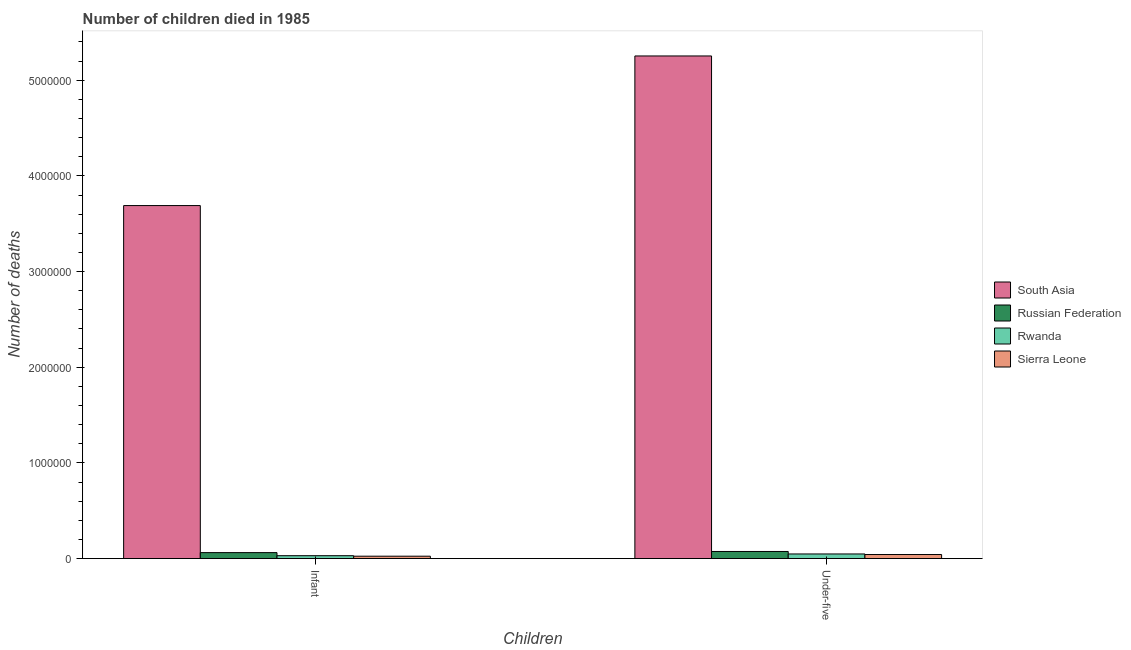How many bars are there on the 2nd tick from the left?
Your response must be concise. 4. What is the label of the 2nd group of bars from the left?
Offer a terse response. Under-five. What is the number of infant deaths in Russian Federation?
Offer a very short reply. 6.23e+04. Across all countries, what is the maximum number of under-five deaths?
Make the answer very short. 5.25e+06. Across all countries, what is the minimum number of under-five deaths?
Ensure brevity in your answer.  4.22e+04. In which country was the number of infant deaths maximum?
Ensure brevity in your answer.  South Asia. In which country was the number of infant deaths minimum?
Provide a succinct answer. Sierra Leone. What is the total number of under-five deaths in the graph?
Give a very brief answer. 5.42e+06. What is the difference between the number of infant deaths in South Asia and that in Russian Federation?
Ensure brevity in your answer.  3.63e+06. What is the difference between the number of infant deaths in Russian Federation and the number of under-five deaths in Sierra Leone?
Your answer should be very brief. 2.01e+04. What is the average number of infant deaths per country?
Make the answer very short. 9.52e+05. What is the difference between the number of under-five deaths and number of infant deaths in Rwanda?
Offer a very short reply. 1.81e+04. What is the ratio of the number of infant deaths in Sierra Leone to that in South Asia?
Keep it short and to the point. 0.01. In how many countries, is the number of infant deaths greater than the average number of infant deaths taken over all countries?
Offer a terse response. 1. What does the 2nd bar from the left in Infant represents?
Your response must be concise. Russian Federation. What does the 1st bar from the right in Infant represents?
Give a very brief answer. Sierra Leone. What is the difference between two consecutive major ticks on the Y-axis?
Give a very brief answer. 1.00e+06. Does the graph contain grids?
Your answer should be very brief. No. Where does the legend appear in the graph?
Your response must be concise. Center right. What is the title of the graph?
Provide a short and direct response. Number of children died in 1985. What is the label or title of the X-axis?
Offer a very short reply. Children. What is the label or title of the Y-axis?
Offer a terse response. Number of deaths. What is the Number of deaths in South Asia in Infant?
Your answer should be very brief. 3.69e+06. What is the Number of deaths of Russian Federation in Infant?
Keep it short and to the point. 6.23e+04. What is the Number of deaths in Rwanda in Infant?
Give a very brief answer. 3.00e+04. What is the Number of deaths in Sierra Leone in Infant?
Offer a very short reply. 2.48e+04. What is the Number of deaths of South Asia in Under-five?
Make the answer very short. 5.25e+06. What is the Number of deaths of Russian Federation in Under-five?
Your response must be concise. 7.41e+04. What is the Number of deaths of Rwanda in Under-five?
Give a very brief answer. 4.81e+04. What is the Number of deaths in Sierra Leone in Under-five?
Keep it short and to the point. 4.22e+04. Across all Children, what is the maximum Number of deaths of South Asia?
Offer a terse response. 5.25e+06. Across all Children, what is the maximum Number of deaths of Russian Federation?
Provide a short and direct response. 7.41e+04. Across all Children, what is the maximum Number of deaths of Rwanda?
Ensure brevity in your answer.  4.81e+04. Across all Children, what is the maximum Number of deaths in Sierra Leone?
Offer a terse response. 4.22e+04. Across all Children, what is the minimum Number of deaths of South Asia?
Offer a very short reply. 3.69e+06. Across all Children, what is the minimum Number of deaths of Russian Federation?
Offer a terse response. 6.23e+04. Across all Children, what is the minimum Number of deaths of Rwanda?
Make the answer very short. 3.00e+04. Across all Children, what is the minimum Number of deaths of Sierra Leone?
Offer a terse response. 2.48e+04. What is the total Number of deaths in South Asia in the graph?
Provide a succinct answer. 8.94e+06. What is the total Number of deaths in Russian Federation in the graph?
Ensure brevity in your answer.  1.36e+05. What is the total Number of deaths of Rwanda in the graph?
Provide a short and direct response. 7.81e+04. What is the total Number of deaths of Sierra Leone in the graph?
Offer a terse response. 6.70e+04. What is the difference between the Number of deaths in South Asia in Infant and that in Under-five?
Offer a very short reply. -1.56e+06. What is the difference between the Number of deaths in Russian Federation in Infant and that in Under-five?
Your response must be concise. -1.18e+04. What is the difference between the Number of deaths in Rwanda in Infant and that in Under-five?
Give a very brief answer. -1.81e+04. What is the difference between the Number of deaths of Sierra Leone in Infant and that in Under-five?
Your answer should be compact. -1.74e+04. What is the difference between the Number of deaths in South Asia in Infant and the Number of deaths in Russian Federation in Under-five?
Offer a terse response. 3.62e+06. What is the difference between the Number of deaths of South Asia in Infant and the Number of deaths of Rwanda in Under-five?
Your answer should be very brief. 3.64e+06. What is the difference between the Number of deaths in South Asia in Infant and the Number of deaths in Sierra Leone in Under-five?
Keep it short and to the point. 3.65e+06. What is the difference between the Number of deaths in Russian Federation in Infant and the Number of deaths in Rwanda in Under-five?
Make the answer very short. 1.42e+04. What is the difference between the Number of deaths of Russian Federation in Infant and the Number of deaths of Sierra Leone in Under-five?
Your answer should be very brief. 2.01e+04. What is the difference between the Number of deaths of Rwanda in Infant and the Number of deaths of Sierra Leone in Under-five?
Keep it short and to the point. -1.22e+04. What is the average Number of deaths of South Asia per Children?
Your response must be concise. 4.47e+06. What is the average Number of deaths in Russian Federation per Children?
Make the answer very short. 6.82e+04. What is the average Number of deaths of Rwanda per Children?
Keep it short and to the point. 3.91e+04. What is the average Number of deaths of Sierra Leone per Children?
Your answer should be compact. 3.35e+04. What is the difference between the Number of deaths of South Asia and Number of deaths of Russian Federation in Infant?
Provide a short and direct response. 3.63e+06. What is the difference between the Number of deaths in South Asia and Number of deaths in Rwanda in Infant?
Your answer should be compact. 3.66e+06. What is the difference between the Number of deaths of South Asia and Number of deaths of Sierra Leone in Infant?
Keep it short and to the point. 3.66e+06. What is the difference between the Number of deaths of Russian Federation and Number of deaths of Rwanda in Infant?
Ensure brevity in your answer.  3.22e+04. What is the difference between the Number of deaths in Russian Federation and Number of deaths in Sierra Leone in Infant?
Provide a short and direct response. 3.75e+04. What is the difference between the Number of deaths of Rwanda and Number of deaths of Sierra Leone in Infant?
Your response must be concise. 5291. What is the difference between the Number of deaths in South Asia and Number of deaths in Russian Federation in Under-five?
Offer a terse response. 5.18e+06. What is the difference between the Number of deaths in South Asia and Number of deaths in Rwanda in Under-five?
Provide a succinct answer. 5.21e+06. What is the difference between the Number of deaths of South Asia and Number of deaths of Sierra Leone in Under-five?
Provide a short and direct response. 5.21e+06. What is the difference between the Number of deaths of Russian Federation and Number of deaths of Rwanda in Under-five?
Provide a short and direct response. 2.60e+04. What is the difference between the Number of deaths of Russian Federation and Number of deaths of Sierra Leone in Under-five?
Ensure brevity in your answer.  3.19e+04. What is the difference between the Number of deaths of Rwanda and Number of deaths of Sierra Leone in Under-five?
Your response must be concise. 5899. What is the ratio of the Number of deaths in South Asia in Infant to that in Under-five?
Provide a succinct answer. 0.7. What is the ratio of the Number of deaths of Russian Federation in Infant to that in Under-five?
Ensure brevity in your answer.  0.84. What is the ratio of the Number of deaths of Rwanda in Infant to that in Under-five?
Your answer should be very brief. 0.62. What is the ratio of the Number of deaths in Sierra Leone in Infant to that in Under-five?
Keep it short and to the point. 0.59. What is the difference between the highest and the second highest Number of deaths in South Asia?
Provide a succinct answer. 1.56e+06. What is the difference between the highest and the second highest Number of deaths in Russian Federation?
Your answer should be compact. 1.18e+04. What is the difference between the highest and the second highest Number of deaths of Rwanda?
Provide a short and direct response. 1.81e+04. What is the difference between the highest and the second highest Number of deaths in Sierra Leone?
Your response must be concise. 1.74e+04. What is the difference between the highest and the lowest Number of deaths in South Asia?
Your answer should be very brief. 1.56e+06. What is the difference between the highest and the lowest Number of deaths of Russian Federation?
Give a very brief answer. 1.18e+04. What is the difference between the highest and the lowest Number of deaths in Rwanda?
Provide a short and direct response. 1.81e+04. What is the difference between the highest and the lowest Number of deaths of Sierra Leone?
Your response must be concise. 1.74e+04. 